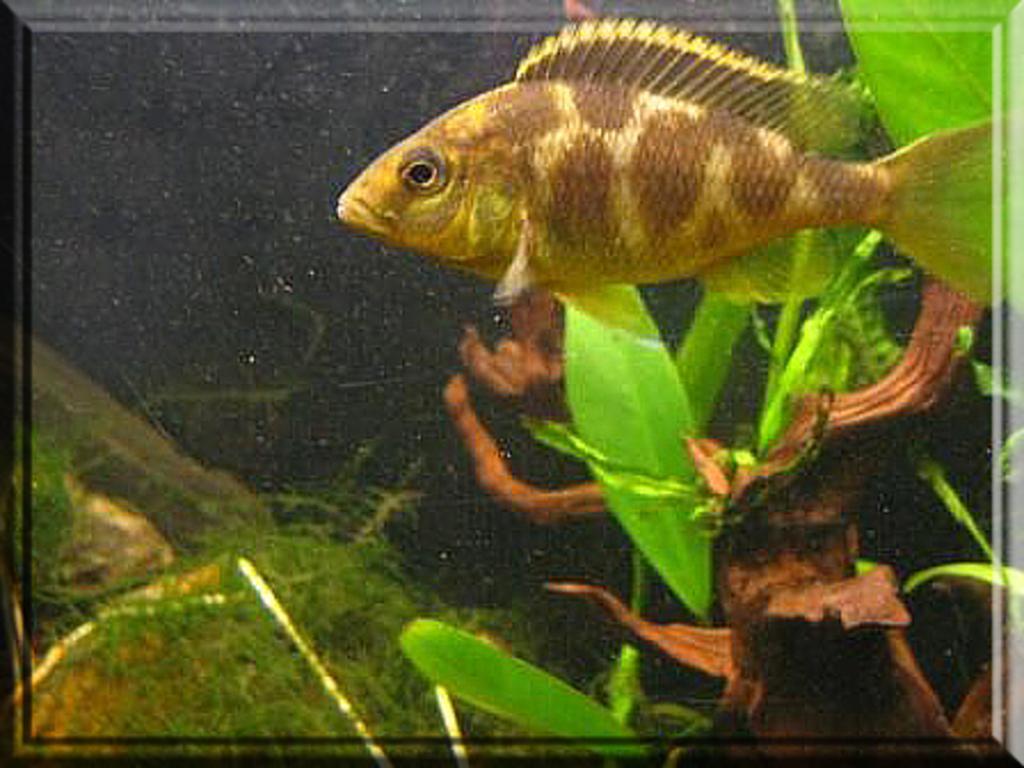Could you give a brief overview of what you see in this image? In this image I can see there is a fish in brown color at the top. At the bottom there are plants in the water. 